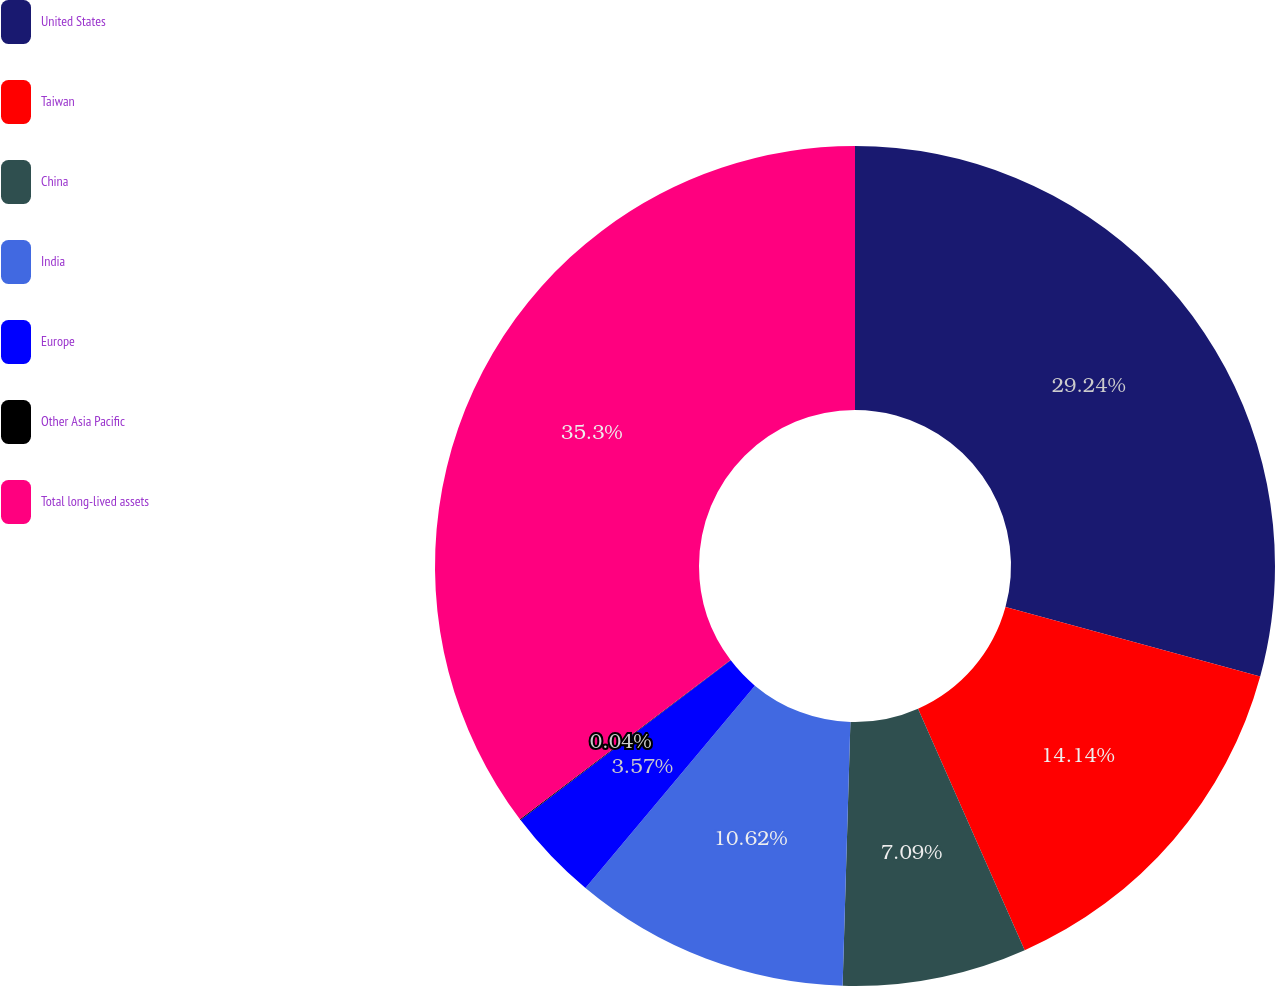<chart> <loc_0><loc_0><loc_500><loc_500><pie_chart><fcel>United States<fcel>Taiwan<fcel>China<fcel>India<fcel>Europe<fcel>Other Asia Pacific<fcel>Total long-lived assets<nl><fcel>29.24%<fcel>14.14%<fcel>7.09%<fcel>10.62%<fcel>3.57%<fcel>0.04%<fcel>35.3%<nl></chart> 